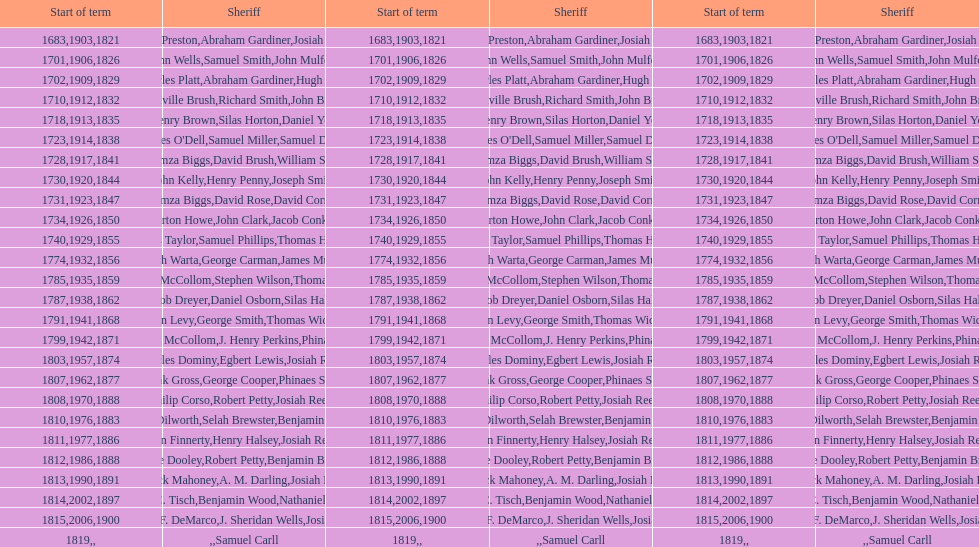Which sheriff came before thomas wickes? James Muirson. 